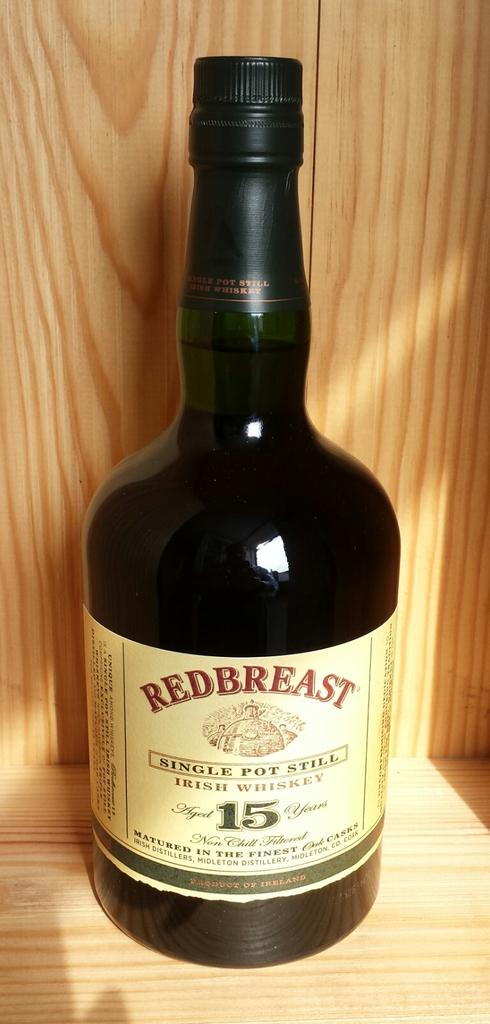<image>
Write a terse but informative summary of the picture. A large bottle of Red Breast branded single pot still is sitting in a wooden cabinet. 